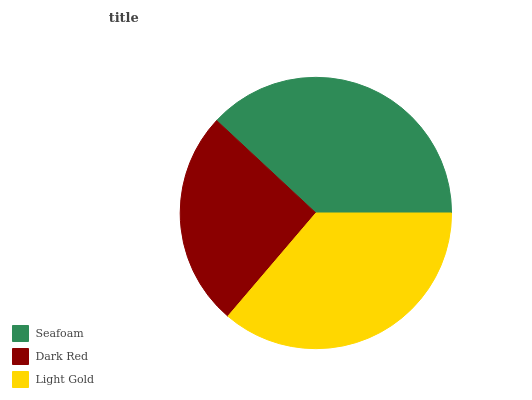Is Dark Red the minimum?
Answer yes or no. Yes. Is Seafoam the maximum?
Answer yes or no. Yes. Is Light Gold the minimum?
Answer yes or no. No. Is Light Gold the maximum?
Answer yes or no. No. Is Light Gold greater than Dark Red?
Answer yes or no. Yes. Is Dark Red less than Light Gold?
Answer yes or no. Yes. Is Dark Red greater than Light Gold?
Answer yes or no. No. Is Light Gold less than Dark Red?
Answer yes or no. No. Is Light Gold the high median?
Answer yes or no. Yes. Is Light Gold the low median?
Answer yes or no. Yes. Is Seafoam the high median?
Answer yes or no. No. Is Dark Red the low median?
Answer yes or no. No. 